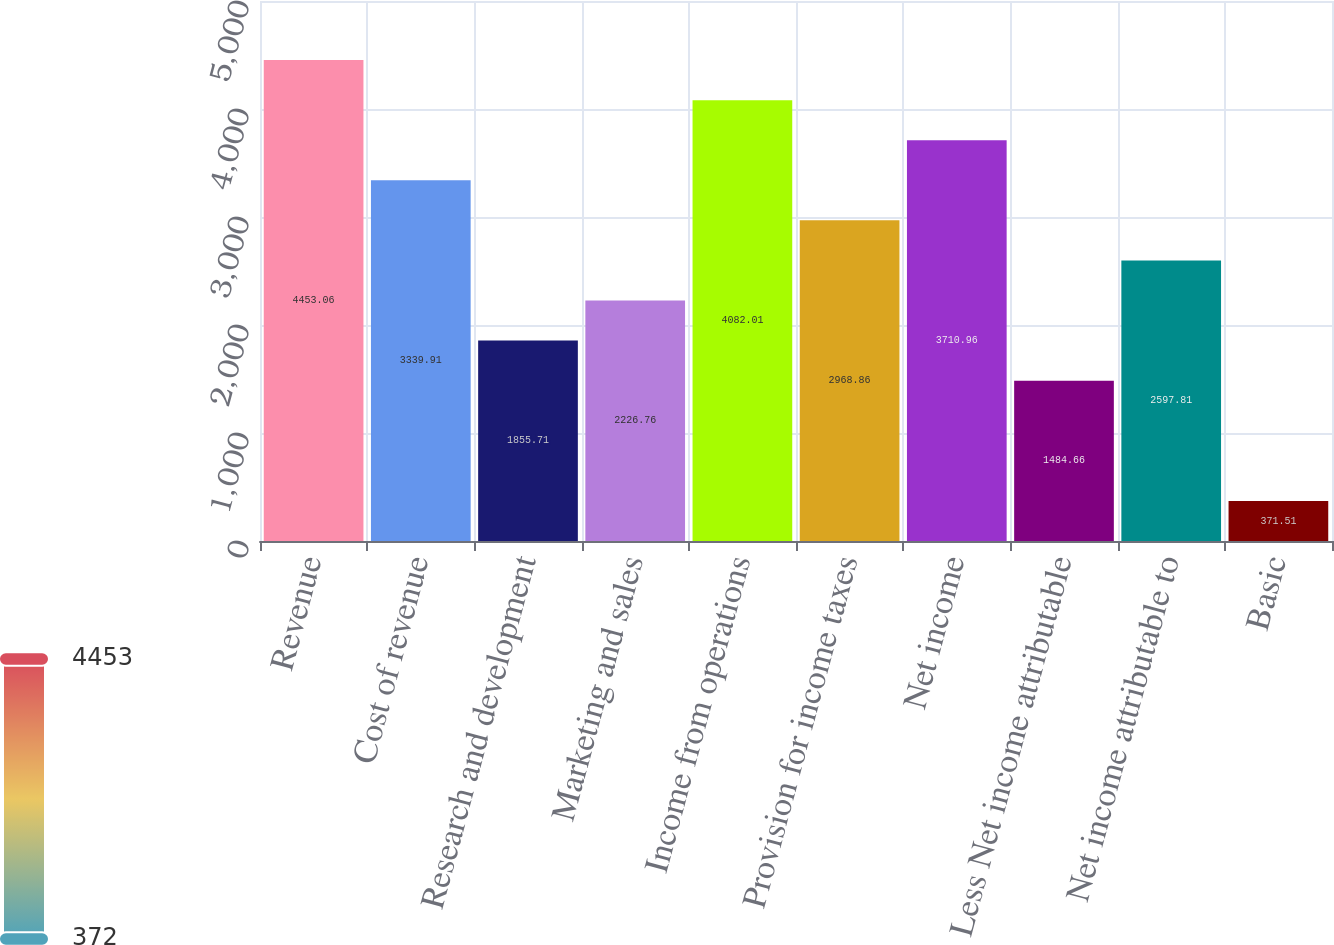<chart> <loc_0><loc_0><loc_500><loc_500><bar_chart><fcel>Revenue<fcel>Cost of revenue<fcel>Research and development<fcel>Marketing and sales<fcel>Income from operations<fcel>Provision for income taxes<fcel>Net income<fcel>Less Net income attributable<fcel>Net income attributable to<fcel>Basic<nl><fcel>4453.06<fcel>3339.91<fcel>1855.71<fcel>2226.76<fcel>4082.01<fcel>2968.86<fcel>3710.96<fcel>1484.66<fcel>2597.81<fcel>371.51<nl></chart> 